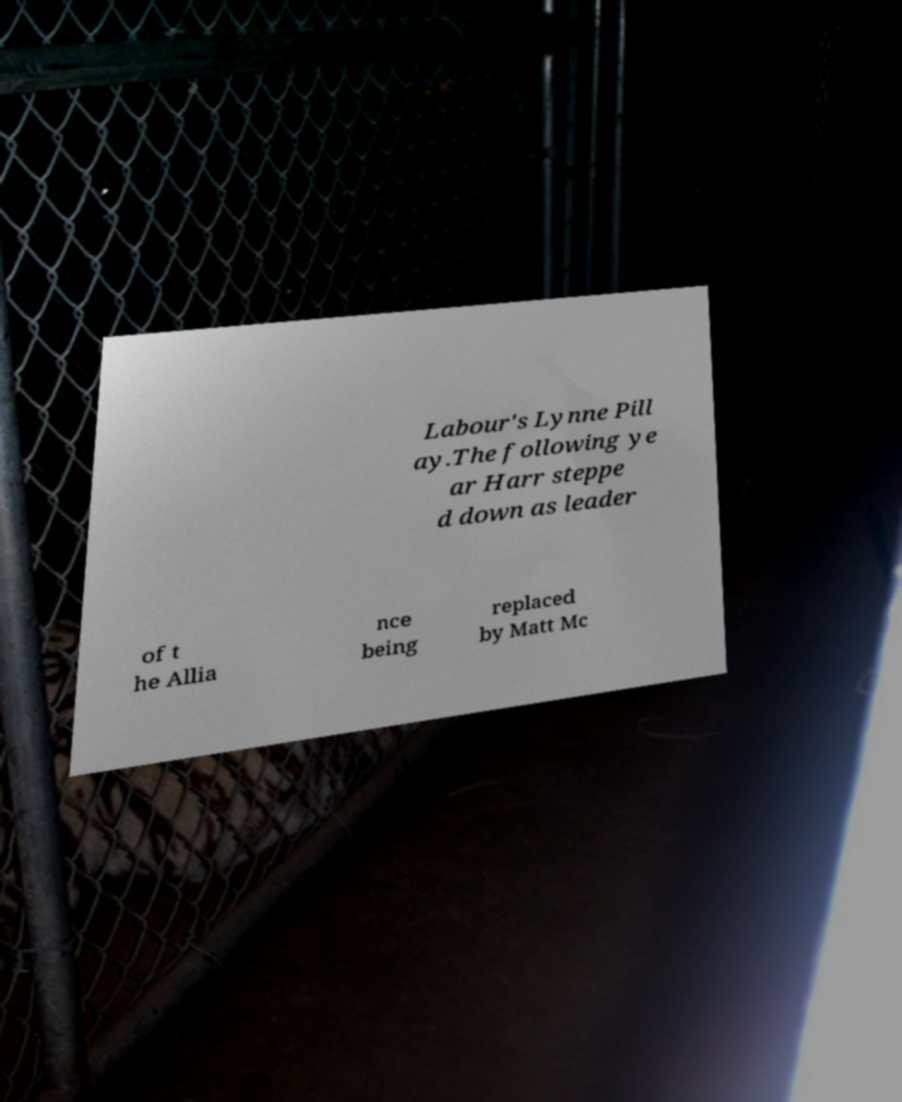Please read and relay the text visible in this image. What does it say? Labour's Lynne Pill ay.The following ye ar Harr steppe d down as leader of t he Allia nce being replaced by Matt Mc 